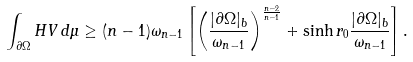Convert formula to latex. <formula><loc_0><loc_0><loc_500><loc_500>\int _ { \partial \Omega } H V \, d \mu \geq ( n - 1 ) \omega _ { n - 1 } \left [ \left ( \frac { | \partial \Omega | _ { b } } { \omega _ { n - 1 } } \right ) ^ { \frac { n - 2 } { n - 1 } } + \sinh r _ { 0 } \frac { | \partial \Omega | _ { b } } { \omega _ { n - 1 } } \right ] .</formula> 